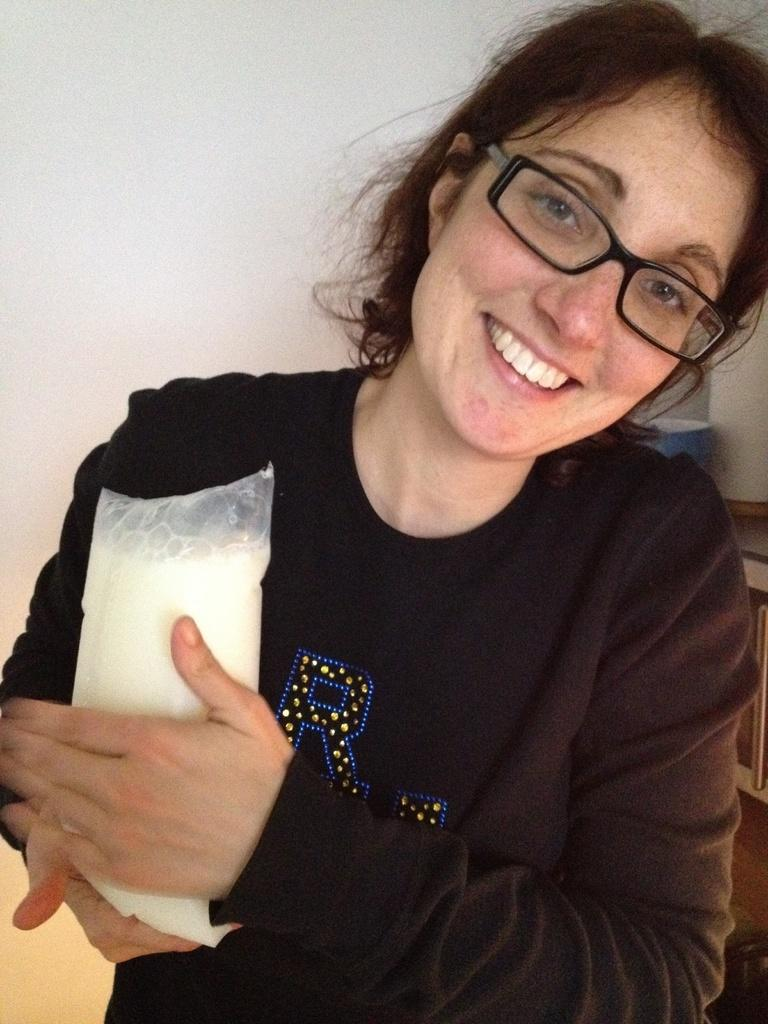Who is present in the image? There is a woman in the image. What is the woman wearing? The woman is wearing a black dress. What is the woman holding in the image? The woman is holding a milk. Where is the woman standing in the image? The woman is standing near a wall. What other object can be seen in the image? There is a cup on a table in the image. What type of war is being discussed by the woman in the image? There is no discussion of war in the image; the woman is holding a milk and standing near a wall. 